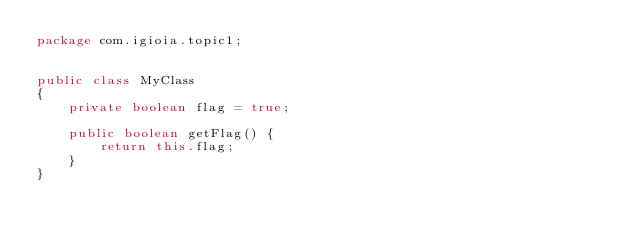<code> <loc_0><loc_0><loc_500><loc_500><_Java_>package com.igioia.topic1;


public class MyClass
{
	private boolean flag = true;
	
	public boolean getFlag() {
		return this.flag;
	}
}
</code> 